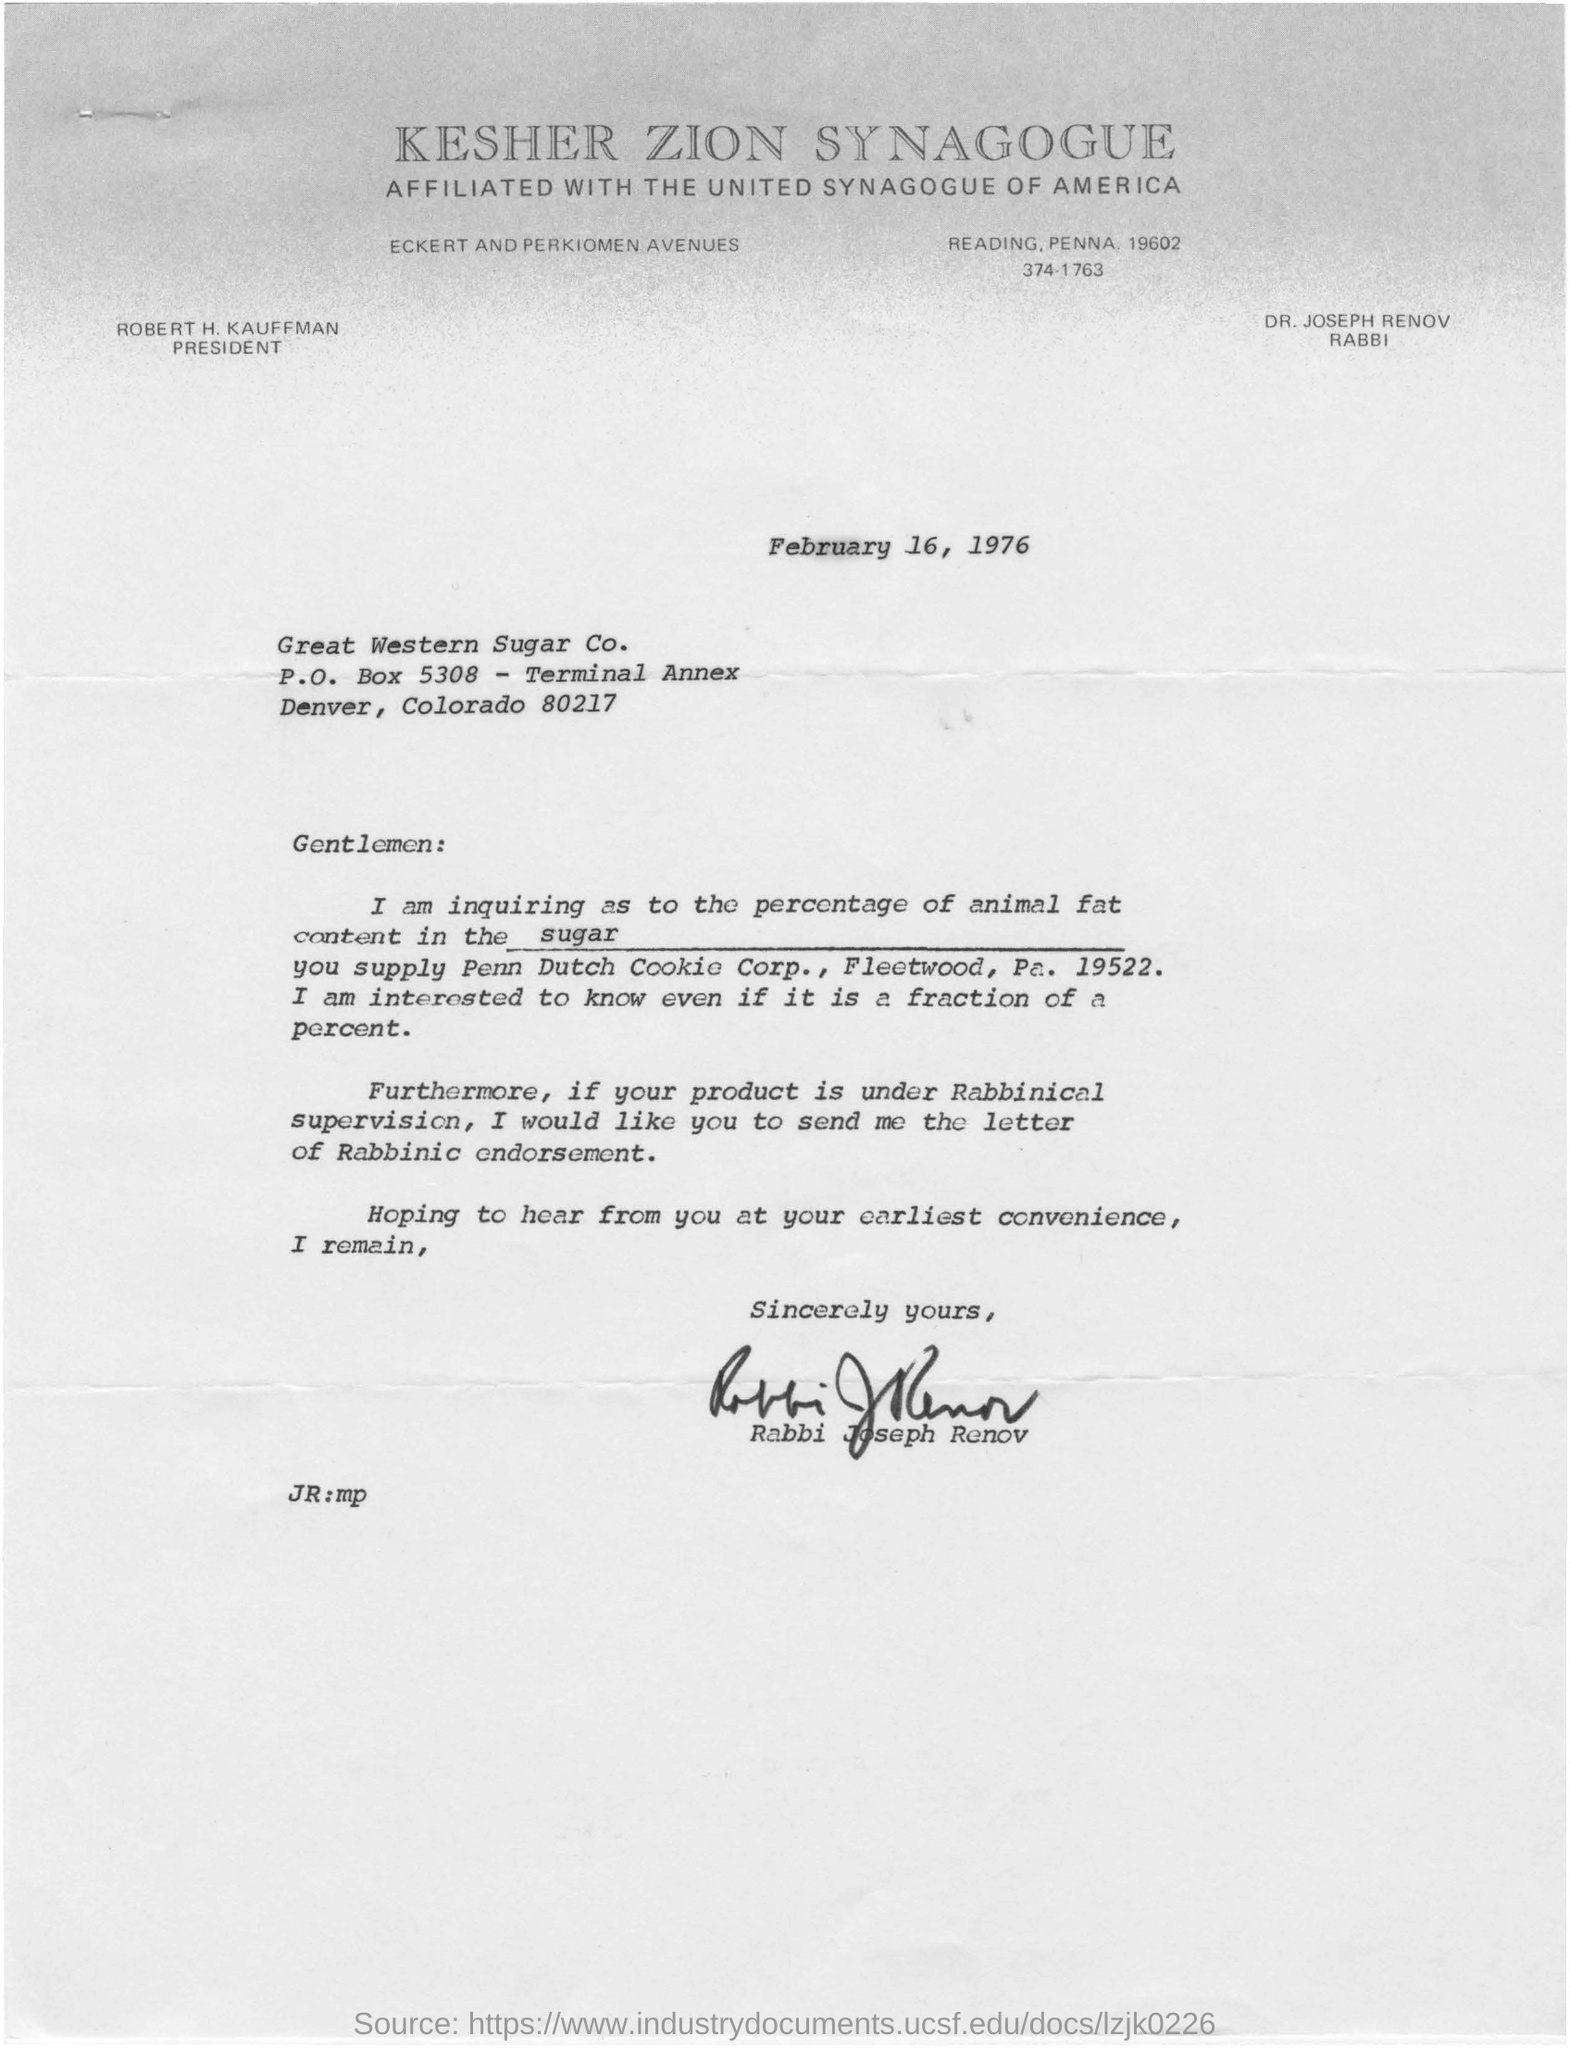What is the heading of the document?
Your answer should be compact. KESHER ZION SYNAGOGUE. What is the date mentioned?
Your answer should be very brief. February 16, 1976. By whom is this document written?
Offer a terse response. Rabbi Joseph Renov. The writer is enquiring about percentage of what in sugar?
Offer a terse response. Animal fat. 